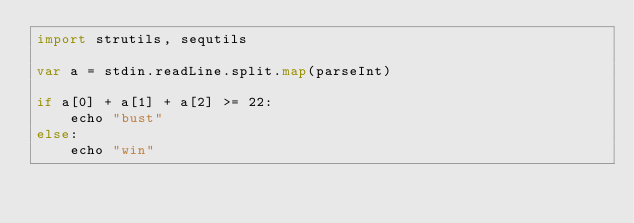Convert code to text. <code><loc_0><loc_0><loc_500><loc_500><_Nim_>import strutils, sequtils

var a = stdin.readLine.split.map(parseInt)

if a[0] + a[1] + a[2] >= 22:
    echo "bust"
else:
    echo "win"
</code> 